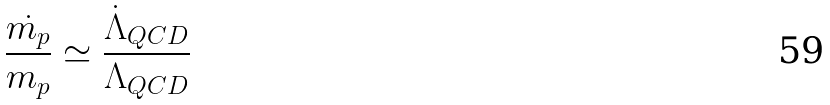<formula> <loc_0><loc_0><loc_500><loc_500>\frac { \dot { m _ { p } } } { m _ { p } } \simeq \frac { \dot { \Lambda } _ { Q C D } } { \Lambda _ { Q C D } }</formula> 